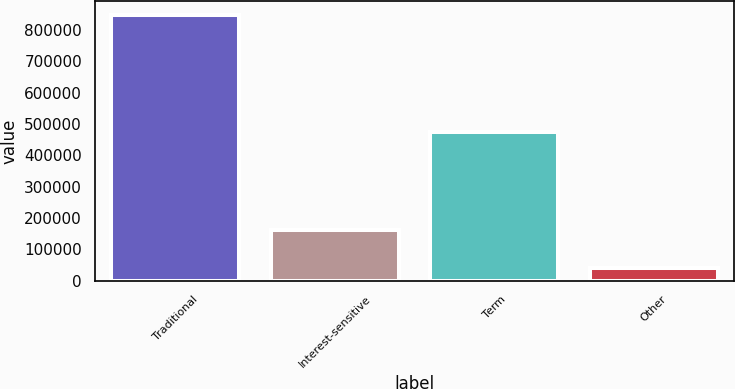Convert chart to OTSL. <chart><loc_0><loc_0><loc_500><loc_500><bar_chart><fcel>Traditional<fcel>Interest-sensitive<fcel>Term<fcel>Other<nl><fcel>848405<fcel>162694<fcel>473061<fcel>39175<nl></chart> 